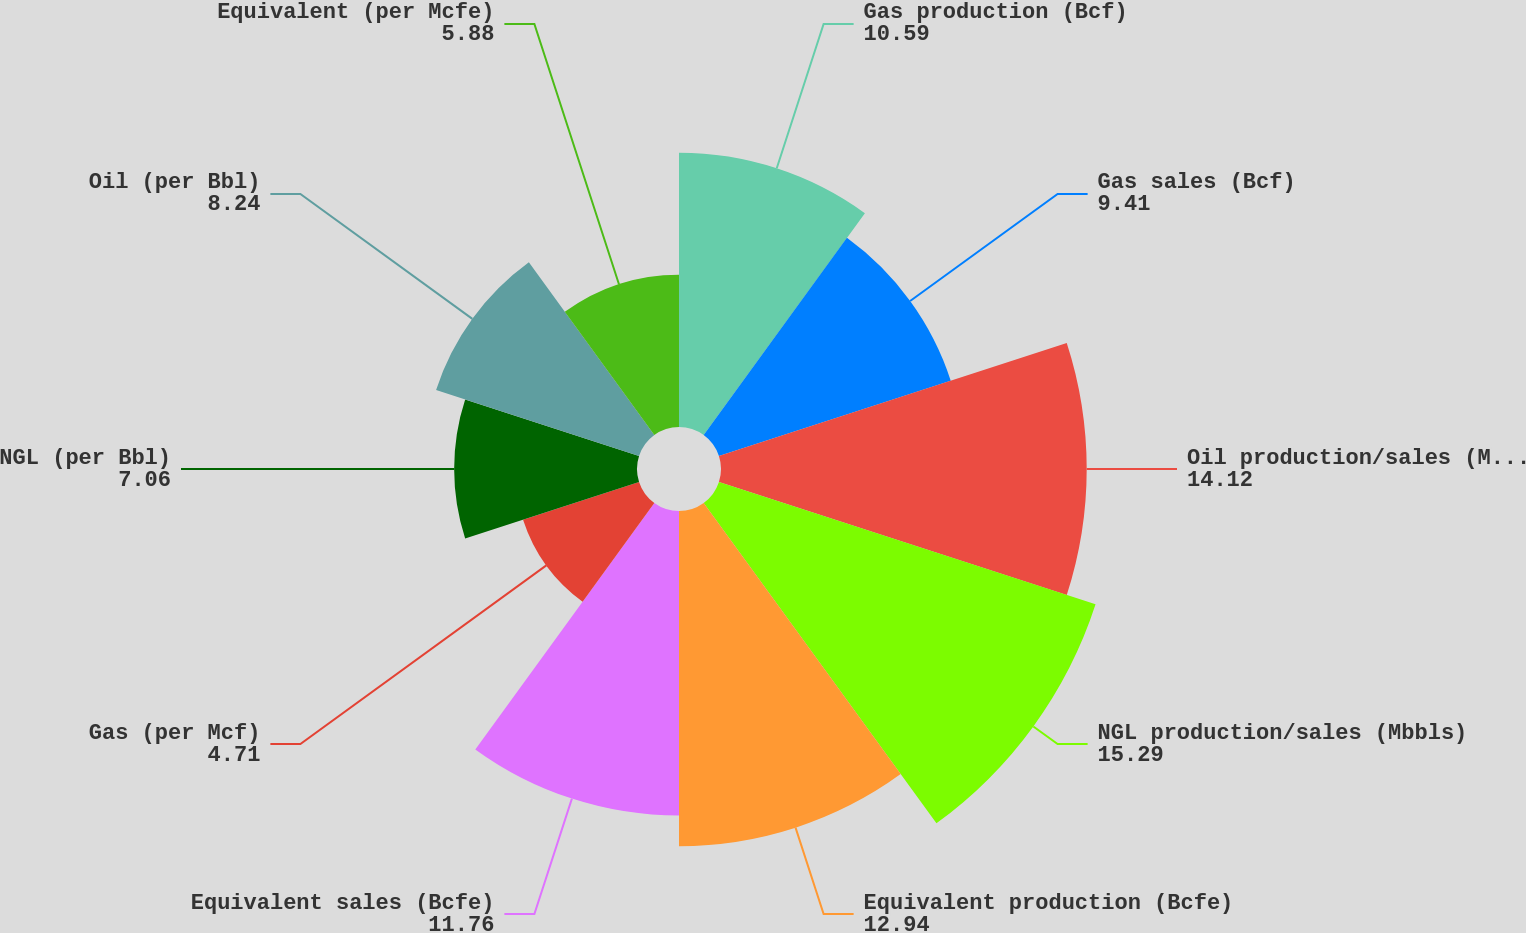Convert chart. <chart><loc_0><loc_0><loc_500><loc_500><pie_chart><fcel>Gas production (Bcf)<fcel>Gas sales (Bcf)<fcel>Oil production/sales (Mbbls)<fcel>NGL production/sales (Mbbls)<fcel>Equivalent production (Bcfe)<fcel>Equivalent sales (Bcfe)<fcel>Gas (per Mcf)<fcel>NGL (per Bbl)<fcel>Oil (per Bbl)<fcel>Equivalent (per Mcfe)<nl><fcel>10.59%<fcel>9.41%<fcel>14.12%<fcel>15.29%<fcel>12.94%<fcel>11.76%<fcel>4.71%<fcel>7.06%<fcel>8.24%<fcel>5.88%<nl></chart> 